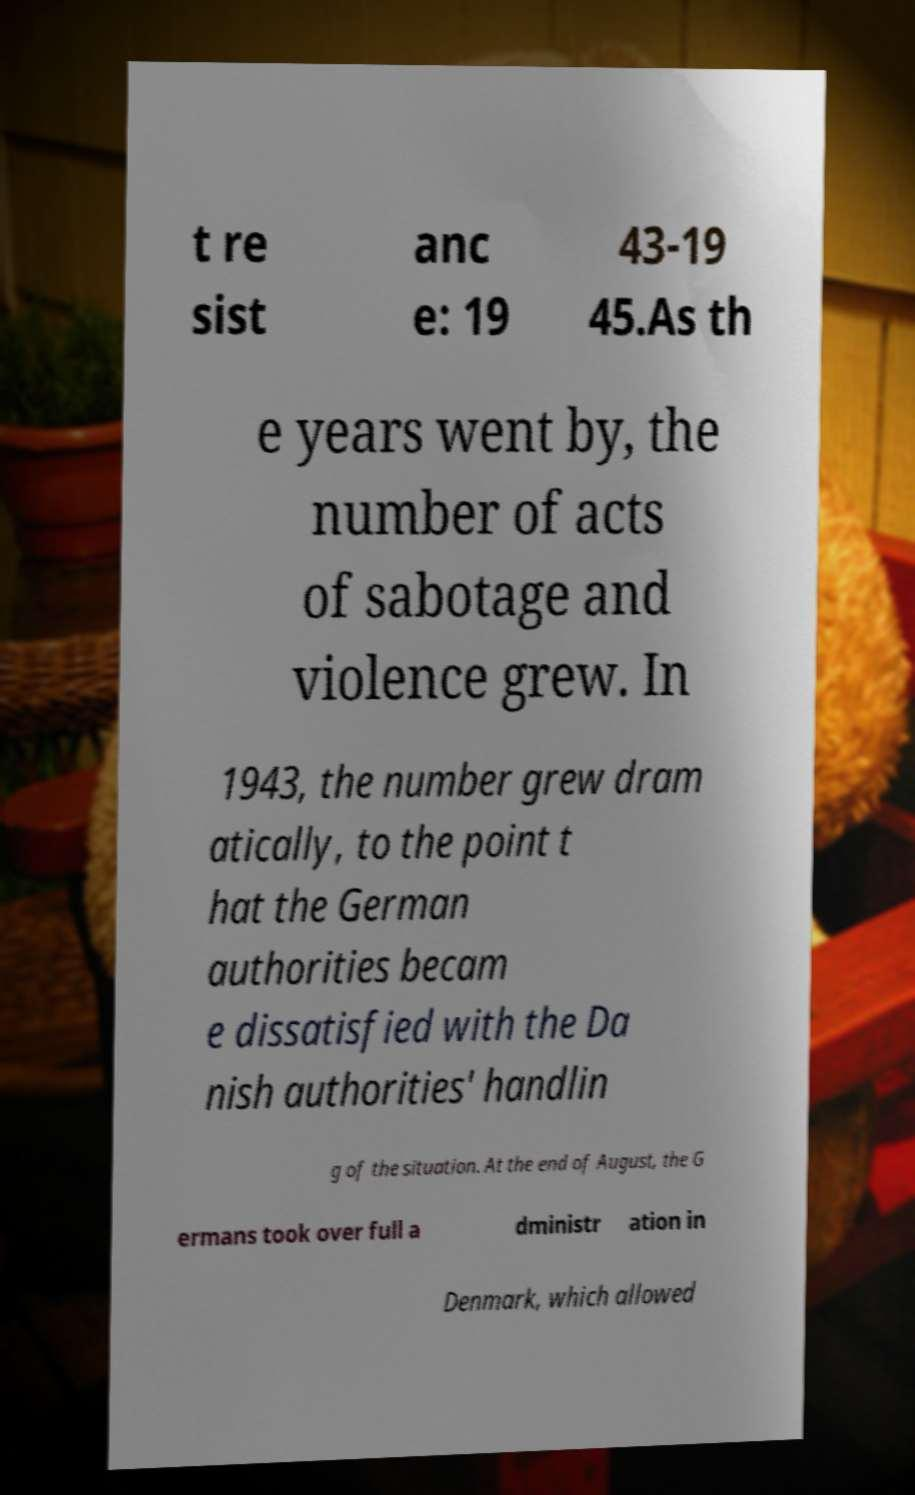For documentation purposes, I need the text within this image transcribed. Could you provide that? t re sist anc e: 19 43-19 45.As th e years went by, the number of acts of sabotage and violence grew. In 1943, the number grew dram atically, to the point t hat the German authorities becam e dissatisfied with the Da nish authorities' handlin g of the situation. At the end of August, the G ermans took over full a dministr ation in Denmark, which allowed 